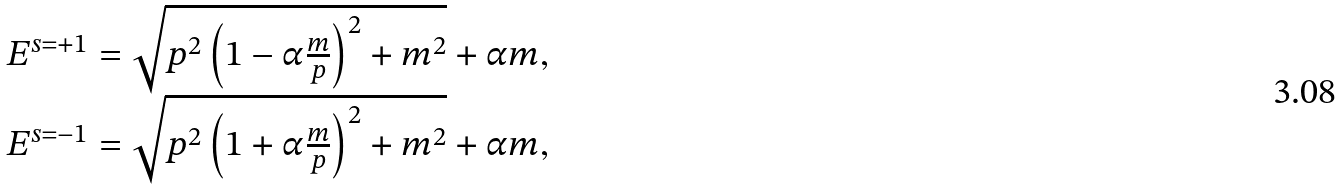Convert formula to latex. <formula><loc_0><loc_0><loc_500><loc_500>\begin{array} { c } E ^ { s = + 1 } = { \sqrt { { p } ^ { 2 } \left ( 1 - \alpha \frac { m } { p } \right ) ^ { 2 } + m ^ { 2 } } + \alpha m } , \\ E ^ { s = - 1 } = { \sqrt { { p } ^ { 2 } \left ( 1 + \alpha \frac { m } { p } \right ) ^ { 2 } + m ^ { 2 } } + \alpha m } , \end{array}</formula> 